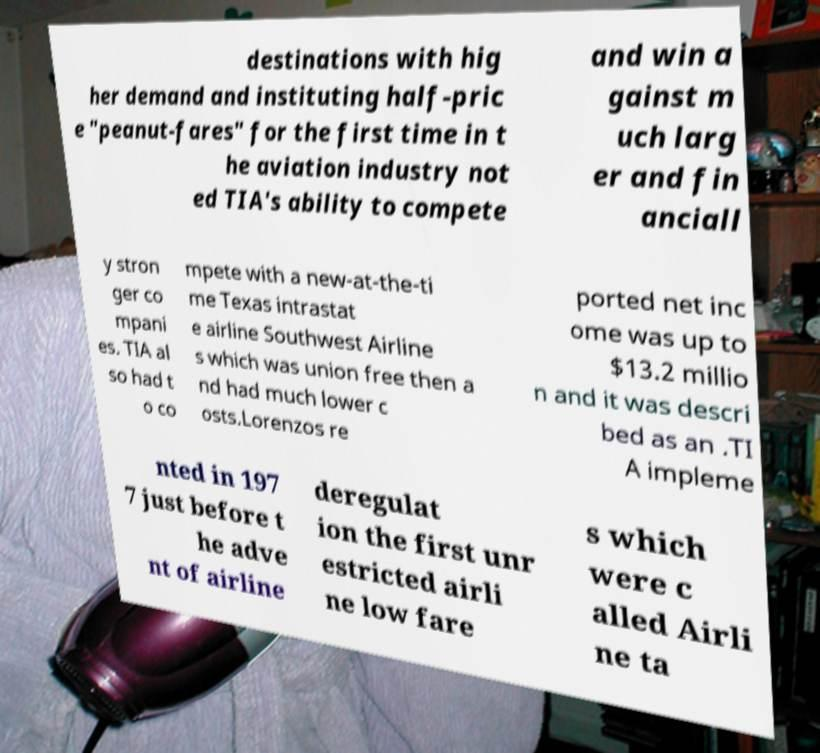Could you assist in decoding the text presented in this image and type it out clearly? destinations with hig her demand and instituting half-pric e "peanut-fares" for the first time in t he aviation industry not ed TIA's ability to compete and win a gainst m uch larg er and fin anciall y stron ger co mpani es. TIA al so had t o co mpete with a new-at-the-ti me Texas intrastat e airline Southwest Airline s which was union free then a nd had much lower c osts.Lorenzos re ported net inc ome was up to $13.2 millio n and it was descri bed as an .TI A impleme nted in 197 7 just before t he adve nt of airline deregulat ion the first unr estricted airli ne low fare s which were c alled Airli ne ta 